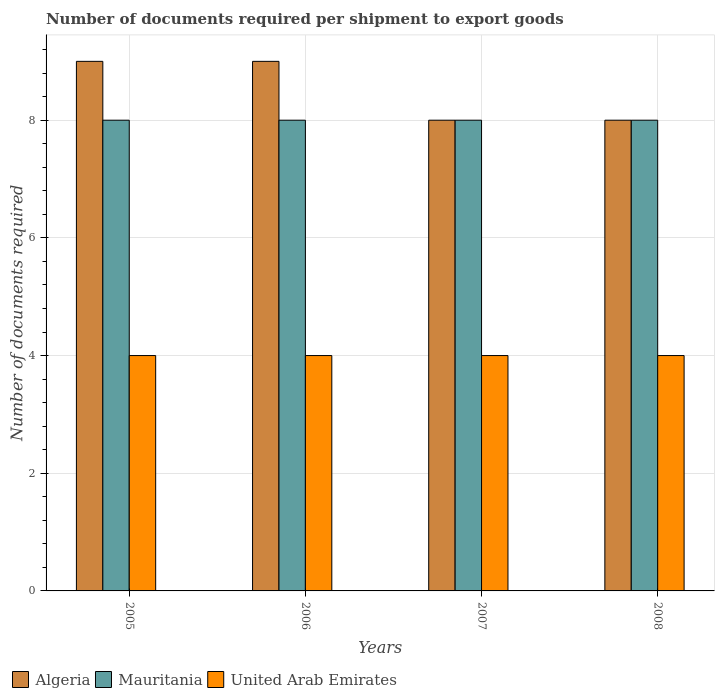Are the number of bars per tick equal to the number of legend labels?
Your answer should be very brief. Yes. Are the number of bars on each tick of the X-axis equal?
Make the answer very short. Yes. How many bars are there on the 1st tick from the left?
Your response must be concise. 3. What is the label of the 3rd group of bars from the left?
Offer a very short reply. 2007. In how many cases, is the number of bars for a given year not equal to the number of legend labels?
Provide a short and direct response. 0. What is the number of documents required per shipment to export goods in Mauritania in 2008?
Offer a terse response. 8. Across all years, what is the maximum number of documents required per shipment to export goods in Algeria?
Ensure brevity in your answer.  9. Across all years, what is the minimum number of documents required per shipment to export goods in United Arab Emirates?
Your answer should be compact. 4. In which year was the number of documents required per shipment to export goods in United Arab Emirates minimum?
Your answer should be very brief. 2005. What is the total number of documents required per shipment to export goods in Algeria in the graph?
Your answer should be very brief. 34. What is the difference between the number of documents required per shipment to export goods in Mauritania in 2007 and that in 2008?
Offer a terse response. 0. What is the difference between the number of documents required per shipment to export goods in United Arab Emirates in 2008 and the number of documents required per shipment to export goods in Mauritania in 2007?
Your answer should be very brief. -4. In the year 2005, what is the difference between the number of documents required per shipment to export goods in Mauritania and number of documents required per shipment to export goods in Algeria?
Ensure brevity in your answer.  -1. In how many years, is the number of documents required per shipment to export goods in Algeria greater than 1.6?
Your response must be concise. 4. Is the number of documents required per shipment to export goods in Mauritania in 2005 less than that in 2008?
Ensure brevity in your answer.  No. Is the difference between the number of documents required per shipment to export goods in Mauritania in 2005 and 2006 greater than the difference between the number of documents required per shipment to export goods in Algeria in 2005 and 2006?
Ensure brevity in your answer.  No. What is the difference between the highest and the second highest number of documents required per shipment to export goods in Mauritania?
Ensure brevity in your answer.  0. Is the sum of the number of documents required per shipment to export goods in Mauritania in 2005 and 2008 greater than the maximum number of documents required per shipment to export goods in United Arab Emirates across all years?
Your response must be concise. Yes. What does the 1st bar from the left in 2006 represents?
Ensure brevity in your answer.  Algeria. What does the 2nd bar from the right in 2005 represents?
Offer a very short reply. Mauritania. Is it the case that in every year, the sum of the number of documents required per shipment to export goods in United Arab Emirates and number of documents required per shipment to export goods in Algeria is greater than the number of documents required per shipment to export goods in Mauritania?
Your answer should be very brief. Yes. How many bars are there?
Make the answer very short. 12. How many years are there in the graph?
Provide a succinct answer. 4. Are the values on the major ticks of Y-axis written in scientific E-notation?
Your answer should be very brief. No. Does the graph contain any zero values?
Provide a short and direct response. No. Where does the legend appear in the graph?
Keep it short and to the point. Bottom left. How many legend labels are there?
Ensure brevity in your answer.  3. What is the title of the graph?
Your response must be concise. Number of documents required per shipment to export goods. What is the label or title of the X-axis?
Your response must be concise. Years. What is the label or title of the Y-axis?
Provide a succinct answer. Number of documents required. What is the Number of documents required of Algeria in 2005?
Provide a succinct answer. 9. What is the Number of documents required of Algeria in 2006?
Provide a short and direct response. 9. What is the Number of documents required of United Arab Emirates in 2006?
Your response must be concise. 4. What is the Number of documents required in United Arab Emirates in 2008?
Provide a succinct answer. 4. Across all years, what is the maximum Number of documents required of Algeria?
Offer a very short reply. 9. Across all years, what is the minimum Number of documents required of Algeria?
Your answer should be compact. 8. Across all years, what is the minimum Number of documents required of Mauritania?
Provide a succinct answer. 8. What is the total Number of documents required of United Arab Emirates in the graph?
Ensure brevity in your answer.  16. What is the difference between the Number of documents required of United Arab Emirates in 2005 and that in 2006?
Offer a very short reply. 0. What is the difference between the Number of documents required of Algeria in 2005 and that in 2007?
Make the answer very short. 1. What is the difference between the Number of documents required of United Arab Emirates in 2005 and that in 2007?
Give a very brief answer. 0. What is the difference between the Number of documents required of United Arab Emirates in 2005 and that in 2008?
Your answer should be compact. 0. What is the difference between the Number of documents required in Algeria in 2006 and that in 2007?
Ensure brevity in your answer.  1. What is the difference between the Number of documents required of Mauritania in 2006 and that in 2007?
Offer a terse response. 0. What is the difference between the Number of documents required in United Arab Emirates in 2006 and that in 2008?
Give a very brief answer. 0. What is the difference between the Number of documents required in Mauritania in 2007 and that in 2008?
Your answer should be very brief. 0. What is the difference between the Number of documents required of United Arab Emirates in 2007 and that in 2008?
Make the answer very short. 0. What is the difference between the Number of documents required in Algeria in 2005 and the Number of documents required in United Arab Emirates in 2006?
Your response must be concise. 5. What is the difference between the Number of documents required of Algeria in 2005 and the Number of documents required of Mauritania in 2008?
Your answer should be very brief. 1. What is the difference between the Number of documents required of Algeria in 2005 and the Number of documents required of United Arab Emirates in 2008?
Provide a short and direct response. 5. What is the difference between the Number of documents required of Mauritania in 2005 and the Number of documents required of United Arab Emirates in 2008?
Provide a succinct answer. 4. What is the difference between the Number of documents required of Algeria in 2006 and the Number of documents required of United Arab Emirates in 2007?
Offer a terse response. 5. What is the difference between the Number of documents required in Algeria in 2006 and the Number of documents required in United Arab Emirates in 2008?
Your answer should be compact. 5. What is the difference between the Number of documents required in Mauritania in 2006 and the Number of documents required in United Arab Emirates in 2008?
Give a very brief answer. 4. What is the difference between the Number of documents required in Algeria in 2007 and the Number of documents required in Mauritania in 2008?
Offer a terse response. 0. What is the difference between the Number of documents required of Algeria in 2007 and the Number of documents required of United Arab Emirates in 2008?
Give a very brief answer. 4. What is the difference between the Number of documents required in Mauritania in 2007 and the Number of documents required in United Arab Emirates in 2008?
Offer a very short reply. 4. What is the average Number of documents required in Algeria per year?
Offer a terse response. 8.5. What is the average Number of documents required of Mauritania per year?
Provide a succinct answer. 8. What is the average Number of documents required in United Arab Emirates per year?
Offer a very short reply. 4. In the year 2005, what is the difference between the Number of documents required of Algeria and Number of documents required of United Arab Emirates?
Your answer should be very brief. 5. In the year 2006, what is the difference between the Number of documents required in Algeria and Number of documents required in Mauritania?
Provide a short and direct response. 1. In the year 2006, what is the difference between the Number of documents required of Algeria and Number of documents required of United Arab Emirates?
Give a very brief answer. 5. In the year 2006, what is the difference between the Number of documents required in Mauritania and Number of documents required in United Arab Emirates?
Your answer should be very brief. 4. In the year 2007, what is the difference between the Number of documents required in Algeria and Number of documents required in Mauritania?
Offer a very short reply. 0. In the year 2007, what is the difference between the Number of documents required of Mauritania and Number of documents required of United Arab Emirates?
Offer a very short reply. 4. In the year 2008, what is the difference between the Number of documents required of Algeria and Number of documents required of Mauritania?
Give a very brief answer. 0. In the year 2008, what is the difference between the Number of documents required of Algeria and Number of documents required of United Arab Emirates?
Your answer should be very brief. 4. What is the ratio of the Number of documents required of Mauritania in 2005 to that in 2007?
Give a very brief answer. 1. What is the ratio of the Number of documents required of United Arab Emirates in 2005 to that in 2008?
Give a very brief answer. 1. What is the ratio of the Number of documents required of Algeria in 2006 to that in 2007?
Your response must be concise. 1.12. What is the ratio of the Number of documents required in Mauritania in 2006 to that in 2007?
Keep it short and to the point. 1. What is the ratio of the Number of documents required of United Arab Emirates in 2006 to that in 2007?
Make the answer very short. 1. What is the ratio of the Number of documents required of Mauritania in 2006 to that in 2008?
Your response must be concise. 1. What is the ratio of the Number of documents required of United Arab Emirates in 2007 to that in 2008?
Give a very brief answer. 1. What is the difference between the highest and the second highest Number of documents required of Algeria?
Offer a terse response. 0. What is the difference between the highest and the second highest Number of documents required of Mauritania?
Keep it short and to the point. 0. What is the difference between the highest and the second highest Number of documents required of United Arab Emirates?
Your response must be concise. 0. 